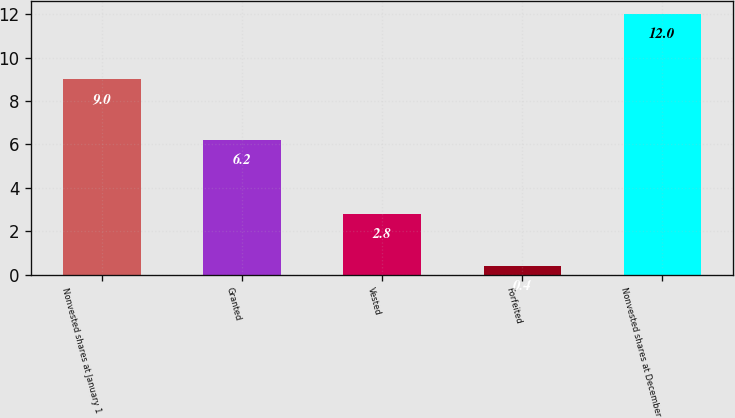Convert chart to OTSL. <chart><loc_0><loc_0><loc_500><loc_500><bar_chart><fcel>Nonvested shares at January 1<fcel>Granted<fcel>Vested<fcel>Forfeited<fcel>Nonvested shares at December<nl><fcel>9<fcel>6.2<fcel>2.8<fcel>0.4<fcel>12<nl></chart> 